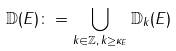Convert formula to latex. <formula><loc_0><loc_0><loc_500><loc_500>{ \mathbb { D } } ( E ) \colon = \bigcup _ { k \in { \mathbb { Z } } , \, k \geq \kappa _ { E } } { \mathbb { D } } _ { k } ( E )</formula> 